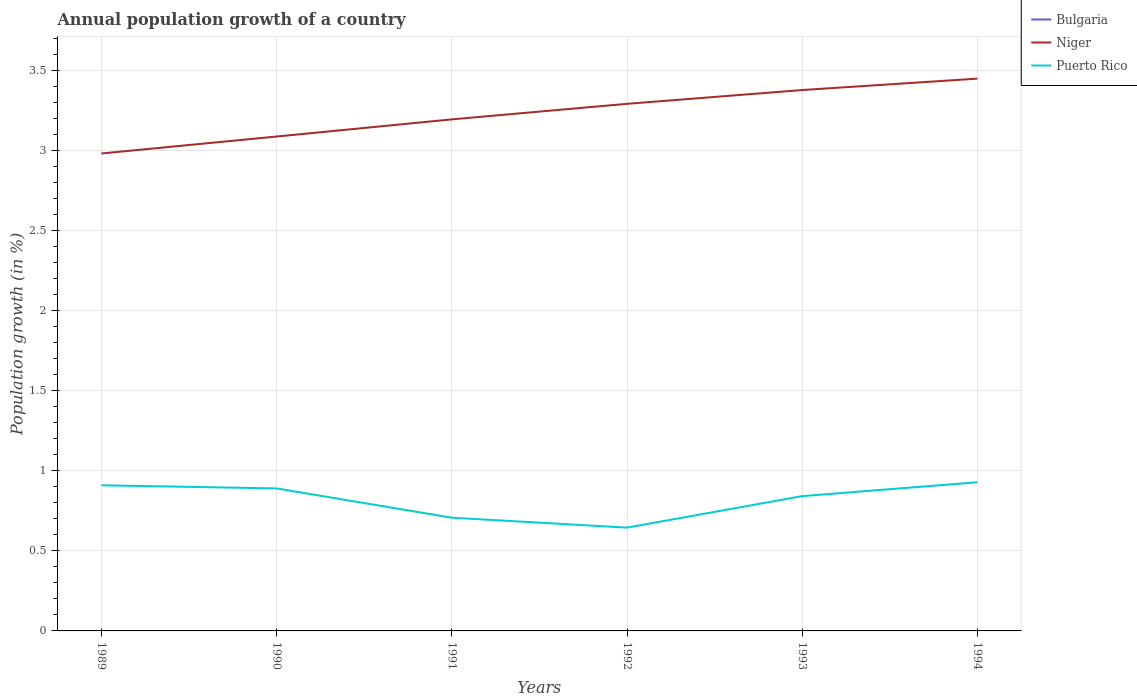Does the line corresponding to Bulgaria intersect with the line corresponding to Puerto Rico?
Your answer should be very brief. No. Across all years, what is the maximum annual population growth in Puerto Rico?
Make the answer very short. 0.65. What is the total annual population growth in Niger in the graph?
Keep it short and to the point. -0.11. What is the difference between the highest and the second highest annual population growth in Puerto Rico?
Your answer should be very brief. 0.28. What is the difference between two consecutive major ticks on the Y-axis?
Your answer should be very brief. 0.5. Are the values on the major ticks of Y-axis written in scientific E-notation?
Provide a succinct answer. No. Does the graph contain any zero values?
Offer a terse response. Yes. Where does the legend appear in the graph?
Give a very brief answer. Top right. How many legend labels are there?
Ensure brevity in your answer.  3. What is the title of the graph?
Your response must be concise. Annual population growth of a country. What is the label or title of the X-axis?
Keep it short and to the point. Years. What is the label or title of the Y-axis?
Offer a very short reply. Population growth (in %). What is the Population growth (in %) in Niger in 1989?
Offer a very short reply. 2.98. What is the Population growth (in %) in Puerto Rico in 1989?
Your answer should be very brief. 0.91. What is the Population growth (in %) in Bulgaria in 1990?
Offer a very short reply. 0. What is the Population growth (in %) of Niger in 1990?
Your answer should be very brief. 3.09. What is the Population growth (in %) in Puerto Rico in 1990?
Your response must be concise. 0.89. What is the Population growth (in %) in Niger in 1991?
Your answer should be very brief. 3.2. What is the Population growth (in %) of Puerto Rico in 1991?
Make the answer very short. 0.71. What is the Population growth (in %) in Niger in 1992?
Provide a short and direct response. 3.29. What is the Population growth (in %) in Puerto Rico in 1992?
Give a very brief answer. 0.65. What is the Population growth (in %) in Niger in 1993?
Your answer should be very brief. 3.38. What is the Population growth (in %) in Puerto Rico in 1993?
Keep it short and to the point. 0.84. What is the Population growth (in %) in Niger in 1994?
Give a very brief answer. 3.45. What is the Population growth (in %) in Puerto Rico in 1994?
Offer a terse response. 0.93. Across all years, what is the maximum Population growth (in %) in Niger?
Your answer should be very brief. 3.45. Across all years, what is the maximum Population growth (in %) of Puerto Rico?
Provide a short and direct response. 0.93. Across all years, what is the minimum Population growth (in %) of Niger?
Offer a terse response. 2.98. Across all years, what is the minimum Population growth (in %) in Puerto Rico?
Your answer should be very brief. 0.65. What is the total Population growth (in %) of Bulgaria in the graph?
Offer a very short reply. 0. What is the total Population growth (in %) in Niger in the graph?
Provide a succinct answer. 19.39. What is the total Population growth (in %) in Puerto Rico in the graph?
Your answer should be compact. 4.92. What is the difference between the Population growth (in %) in Niger in 1989 and that in 1990?
Provide a succinct answer. -0.11. What is the difference between the Population growth (in %) of Puerto Rico in 1989 and that in 1990?
Make the answer very short. 0.02. What is the difference between the Population growth (in %) of Niger in 1989 and that in 1991?
Your answer should be very brief. -0.21. What is the difference between the Population growth (in %) of Puerto Rico in 1989 and that in 1991?
Provide a short and direct response. 0.2. What is the difference between the Population growth (in %) in Niger in 1989 and that in 1992?
Provide a short and direct response. -0.31. What is the difference between the Population growth (in %) of Puerto Rico in 1989 and that in 1992?
Your answer should be compact. 0.26. What is the difference between the Population growth (in %) in Niger in 1989 and that in 1993?
Give a very brief answer. -0.4. What is the difference between the Population growth (in %) of Puerto Rico in 1989 and that in 1993?
Provide a succinct answer. 0.07. What is the difference between the Population growth (in %) in Niger in 1989 and that in 1994?
Give a very brief answer. -0.47. What is the difference between the Population growth (in %) in Puerto Rico in 1989 and that in 1994?
Offer a terse response. -0.02. What is the difference between the Population growth (in %) in Niger in 1990 and that in 1991?
Keep it short and to the point. -0.11. What is the difference between the Population growth (in %) of Puerto Rico in 1990 and that in 1991?
Ensure brevity in your answer.  0.18. What is the difference between the Population growth (in %) in Niger in 1990 and that in 1992?
Give a very brief answer. -0.2. What is the difference between the Population growth (in %) in Puerto Rico in 1990 and that in 1992?
Ensure brevity in your answer.  0.24. What is the difference between the Population growth (in %) of Niger in 1990 and that in 1993?
Offer a very short reply. -0.29. What is the difference between the Population growth (in %) in Puerto Rico in 1990 and that in 1993?
Give a very brief answer. 0.05. What is the difference between the Population growth (in %) in Niger in 1990 and that in 1994?
Your answer should be compact. -0.36. What is the difference between the Population growth (in %) of Puerto Rico in 1990 and that in 1994?
Provide a short and direct response. -0.04. What is the difference between the Population growth (in %) in Niger in 1991 and that in 1992?
Offer a terse response. -0.1. What is the difference between the Population growth (in %) of Puerto Rico in 1991 and that in 1992?
Your response must be concise. 0.06. What is the difference between the Population growth (in %) of Niger in 1991 and that in 1993?
Provide a short and direct response. -0.18. What is the difference between the Population growth (in %) in Puerto Rico in 1991 and that in 1993?
Offer a terse response. -0.13. What is the difference between the Population growth (in %) of Niger in 1991 and that in 1994?
Give a very brief answer. -0.25. What is the difference between the Population growth (in %) of Puerto Rico in 1991 and that in 1994?
Your answer should be very brief. -0.22. What is the difference between the Population growth (in %) in Niger in 1992 and that in 1993?
Provide a short and direct response. -0.09. What is the difference between the Population growth (in %) in Puerto Rico in 1992 and that in 1993?
Provide a succinct answer. -0.2. What is the difference between the Population growth (in %) of Niger in 1992 and that in 1994?
Make the answer very short. -0.16. What is the difference between the Population growth (in %) in Puerto Rico in 1992 and that in 1994?
Keep it short and to the point. -0.28. What is the difference between the Population growth (in %) of Niger in 1993 and that in 1994?
Offer a very short reply. -0.07. What is the difference between the Population growth (in %) of Puerto Rico in 1993 and that in 1994?
Make the answer very short. -0.09. What is the difference between the Population growth (in %) of Niger in 1989 and the Population growth (in %) of Puerto Rico in 1990?
Provide a short and direct response. 2.09. What is the difference between the Population growth (in %) in Niger in 1989 and the Population growth (in %) in Puerto Rico in 1991?
Ensure brevity in your answer.  2.28. What is the difference between the Population growth (in %) of Niger in 1989 and the Population growth (in %) of Puerto Rico in 1992?
Offer a very short reply. 2.34. What is the difference between the Population growth (in %) in Niger in 1989 and the Population growth (in %) in Puerto Rico in 1993?
Offer a terse response. 2.14. What is the difference between the Population growth (in %) in Niger in 1989 and the Population growth (in %) in Puerto Rico in 1994?
Provide a succinct answer. 2.05. What is the difference between the Population growth (in %) in Niger in 1990 and the Population growth (in %) in Puerto Rico in 1991?
Keep it short and to the point. 2.38. What is the difference between the Population growth (in %) of Niger in 1990 and the Population growth (in %) of Puerto Rico in 1992?
Ensure brevity in your answer.  2.44. What is the difference between the Population growth (in %) in Niger in 1990 and the Population growth (in %) in Puerto Rico in 1993?
Ensure brevity in your answer.  2.25. What is the difference between the Population growth (in %) of Niger in 1990 and the Population growth (in %) of Puerto Rico in 1994?
Your response must be concise. 2.16. What is the difference between the Population growth (in %) in Niger in 1991 and the Population growth (in %) in Puerto Rico in 1992?
Provide a succinct answer. 2.55. What is the difference between the Population growth (in %) of Niger in 1991 and the Population growth (in %) of Puerto Rico in 1993?
Provide a succinct answer. 2.35. What is the difference between the Population growth (in %) in Niger in 1991 and the Population growth (in %) in Puerto Rico in 1994?
Give a very brief answer. 2.27. What is the difference between the Population growth (in %) of Niger in 1992 and the Population growth (in %) of Puerto Rico in 1993?
Your answer should be very brief. 2.45. What is the difference between the Population growth (in %) in Niger in 1992 and the Population growth (in %) in Puerto Rico in 1994?
Offer a very short reply. 2.36. What is the difference between the Population growth (in %) of Niger in 1993 and the Population growth (in %) of Puerto Rico in 1994?
Provide a short and direct response. 2.45. What is the average Population growth (in %) of Niger per year?
Keep it short and to the point. 3.23. What is the average Population growth (in %) of Puerto Rico per year?
Your response must be concise. 0.82. In the year 1989, what is the difference between the Population growth (in %) in Niger and Population growth (in %) in Puerto Rico?
Provide a short and direct response. 2.07. In the year 1990, what is the difference between the Population growth (in %) of Niger and Population growth (in %) of Puerto Rico?
Ensure brevity in your answer.  2.2. In the year 1991, what is the difference between the Population growth (in %) of Niger and Population growth (in %) of Puerto Rico?
Your response must be concise. 2.49. In the year 1992, what is the difference between the Population growth (in %) of Niger and Population growth (in %) of Puerto Rico?
Ensure brevity in your answer.  2.65. In the year 1993, what is the difference between the Population growth (in %) in Niger and Population growth (in %) in Puerto Rico?
Ensure brevity in your answer.  2.54. In the year 1994, what is the difference between the Population growth (in %) of Niger and Population growth (in %) of Puerto Rico?
Keep it short and to the point. 2.52. What is the ratio of the Population growth (in %) of Niger in 1989 to that in 1990?
Offer a terse response. 0.97. What is the ratio of the Population growth (in %) of Puerto Rico in 1989 to that in 1990?
Provide a short and direct response. 1.02. What is the ratio of the Population growth (in %) of Niger in 1989 to that in 1991?
Keep it short and to the point. 0.93. What is the ratio of the Population growth (in %) in Puerto Rico in 1989 to that in 1991?
Provide a short and direct response. 1.29. What is the ratio of the Population growth (in %) of Niger in 1989 to that in 1992?
Offer a terse response. 0.91. What is the ratio of the Population growth (in %) of Puerto Rico in 1989 to that in 1992?
Offer a terse response. 1.41. What is the ratio of the Population growth (in %) of Niger in 1989 to that in 1993?
Provide a short and direct response. 0.88. What is the ratio of the Population growth (in %) in Puerto Rico in 1989 to that in 1993?
Your answer should be very brief. 1.08. What is the ratio of the Population growth (in %) of Niger in 1989 to that in 1994?
Offer a terse response. 0.86. What is the ratio of the Population growth (in %) in Puerto Rico in 1989 to that in 1994?
Keep it short and to the point. 0.98. What is the ratio of the Population growth (in %) in Niger in 1990 to that in 1991?
Offer a very short reply. 0.97. What is the ratio of the Population growth (in %) in Puerto Rico in 1990 to that in 1991?
Make the answer very short. 1.26. What is the ratio of the Population growth (in %) in Niger in 1990 to that in 1992?
Your response must be concise. 0.94. What is the ratio of the Population growth (in %) of Puerto Rico in 1990 to that in 1992?
Provide a short and direct response. 1.38. What is the ratio of the Population growth (in %) in Niger in 1990 to that in 1993?
Your response must be concise. 0.91. What is the ratio of the Population growth (in %) in Puerto Rico in 1990 to that in 1993?
Keep it short and to the point. 1.06. What is the ratio of the Population growth (in %) of Niger in 1990 to that in 1994?
Ensure brevity in your answer.  0.9. What is the ratio of the Population growth (in %) in Puerto Rico in 1990 to that in 1994?
Offer a very short reply. 0.96. What is the ratio of the Population growth (in %) in Niger in 1991 to that in 1992?
Provide a short and direct response. 0.97. What is the ratio of the Population growth (in %) in Puerto Rico in 1991 to that in 1992?
Your response must be concise. 1.1. What is the ratio of the Population growth (in %) in Niger in 1991 to that in 1993?
Give a very brief answer. 0.95. What is the ratio of the Population growth (in %) in Puerto Rico in 1991 to that in 1993?
Give a very brief answer. 0.84. What is the ratio of the Population growth (in %) of Niger in 1991 to that in 1994?
Your answer should be very brief. 0.93. What is the ratio of the Population growth (in %) in Puerto Rico in 1991 to that in 1994?
Provide a short and direct response. 0.76. What is the ratio of the Population growth (in %) in Niger in 1992 to that in 1993?
Ensure brevity in your answer.  0.97. What is the ratio of the Population growth (in %) of Puerto Rico in 1992 to that in 1993?
Provide a succinct answer. 0.77. What is the ratio of the Population growth (in %) in Niger in 1992 to that in 1994?
Give a very brief answer. 0.95. What is the ratio of the Population growth (in %) in Puerto Rico in 1992 to that in 1994?
Ensure brevity in your answer.  0.69. What is the ratio of the Population growth (in %) of Niger in 1993 to that in 1994?
Your answer should be compact. 0.98. What is the ratio of the Population growth (in %) in Puerto Rico in 1993 to that in 1994?
Provide a short and direct response. 0.91. What is the difference between the highest and the second highest Population growth (in %) of Niger?
Your answer should be compact. 0.07. What is the difference between the highest and the second highest Population growth (in %) of Puerto Rico?
Your answer should be compact. 0.02. What is the difference between the highest and the lowest Population growth (in %) of Niger?
Keep it short and to the point. 0.47. What is the difference between the highest and the lowest Population growth (in %) of Puerto Rico?
Provide a succinct answer. 0.28. 